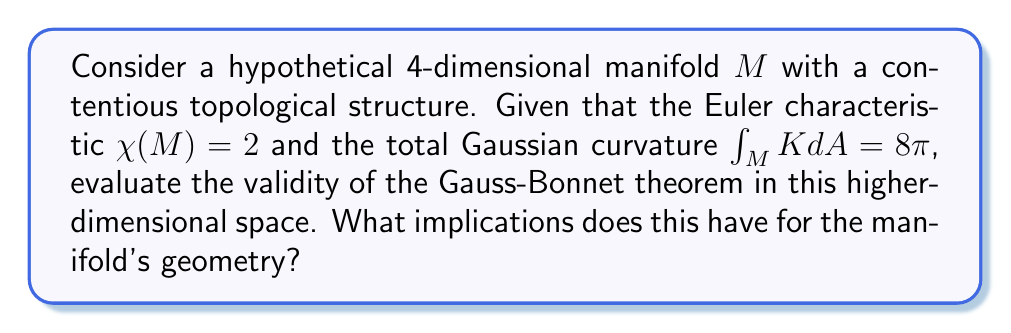Give your solution to this math problem. To assess the validity of the Gauss-Bonnet theorem in this higher-dimensional space, we need to follow these steps:

1) Recall the Gauss-Bonnet theorem for 2-dimensional surfaces:

   $$\int_M K dA + \int_{\partial M} k_g ds = 2\pi\chi(M)$$

   where $K$ is the Gaussian curvature, $k_g$ is the geodesic curvature of the boundary, and $\chi(M)$ is the Euler characteristic.

2) For closed manifolds (without boundary), this simplifies to:

   $$\int_M K dA = 2\pi\chi(M)$$

3) In our case, we're given:
   - $\chi(M) = 2$
   - $\int_M K dA = 8\pi$

4) If the Gauss-Bonnet theorem holds in this 4-dimensional space, we should have:

   $$8\pi = 2\pi(2)$$

5) Indeed, this equality holds true, as both sides equal $4\pi$.

6) This suggests that the Gauss-Bonnet theorem is applicable in this higher-dimensional space, despite its contentious structure.

7) Implications for the manifold's geometry:
   a) The manifold behaves similarly to a 2-dimensional sphere in terms of its total curvature and topology.
   b) This could indicate that the manifold has a relatively simple topological structure, possibly homeomorphic to a 4-sphere.
   c) The contentious nature of the manifold might lie in its metric properties rather than its topological properties.
   d) The applicability of the theorem suggests that some fundamental relationships between curvature and topology extend to higher dimensions, at least in this case.

8) However, caution is needed:
   a) This is a single example and doesn't prove the theorem's general applicability in 4D.
   b) The interpretation of Gaussian curvature in 4D might differ from its 2D counterpart.
   c) There might be hidden assumptions or properties of this specific manifold that allow the theorem to hold.
Answer: The Gauss-Bonnet theorem appears valid for this 4D manifold, implying a sphere-like topology with potential complexities in metric properties. 